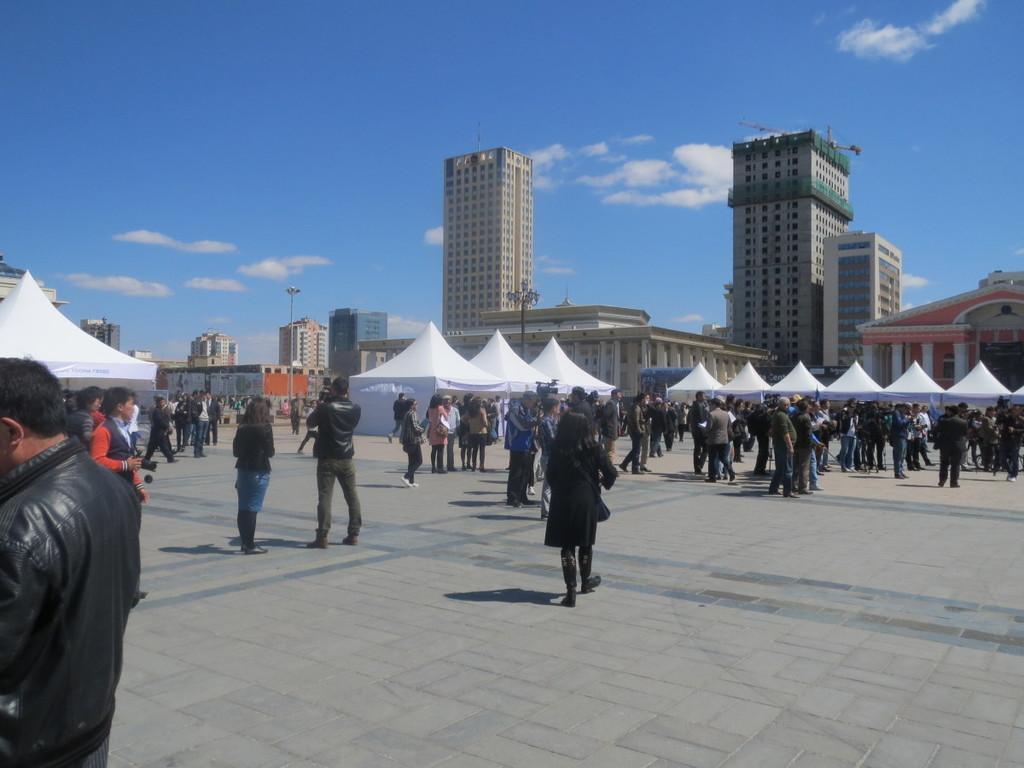Can you describe this image briefly? In this picture I can observe few people walking on the land. In the background I can observe tents and buildings. There are some clouds in the sky. 